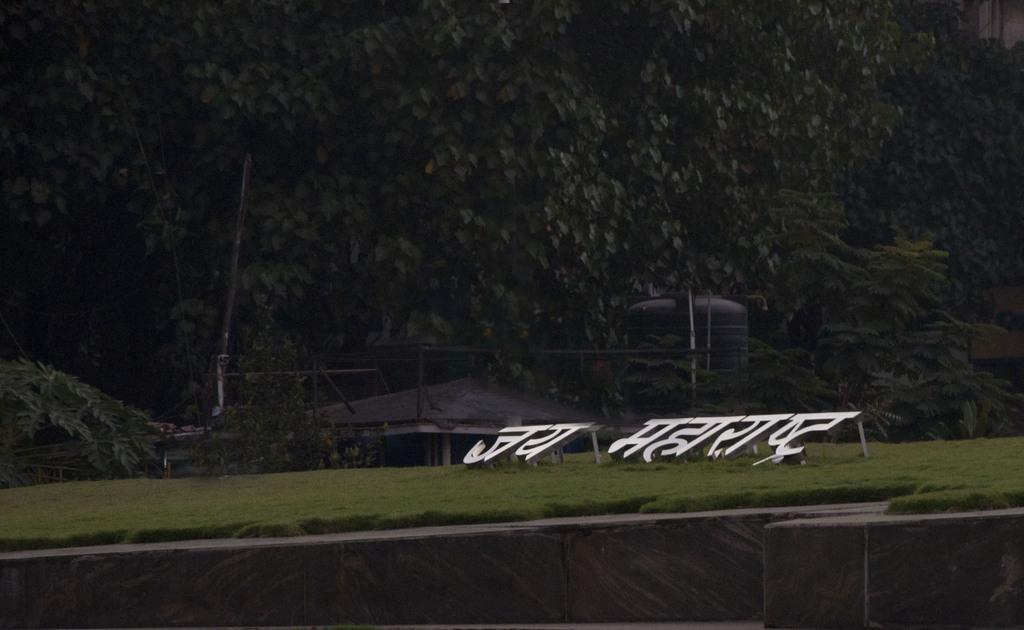What language is used in the text visible on the ground in the image? The text on the ground is in Hindi. What color is the water tank in the image? The water tank is black in color. What can be seen in the background of the image? There are trees in the background of the image. How many dogs are visible in the image? There are no dogs present in the image. What type of haircut is the water tank sporting in the image? The water tank does not have a haircut, as it is an inanimate object. 